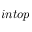Convert formula to latex. <formula><loc_0><loc_0><loc_500><loc_500>i n t o p</formula> 